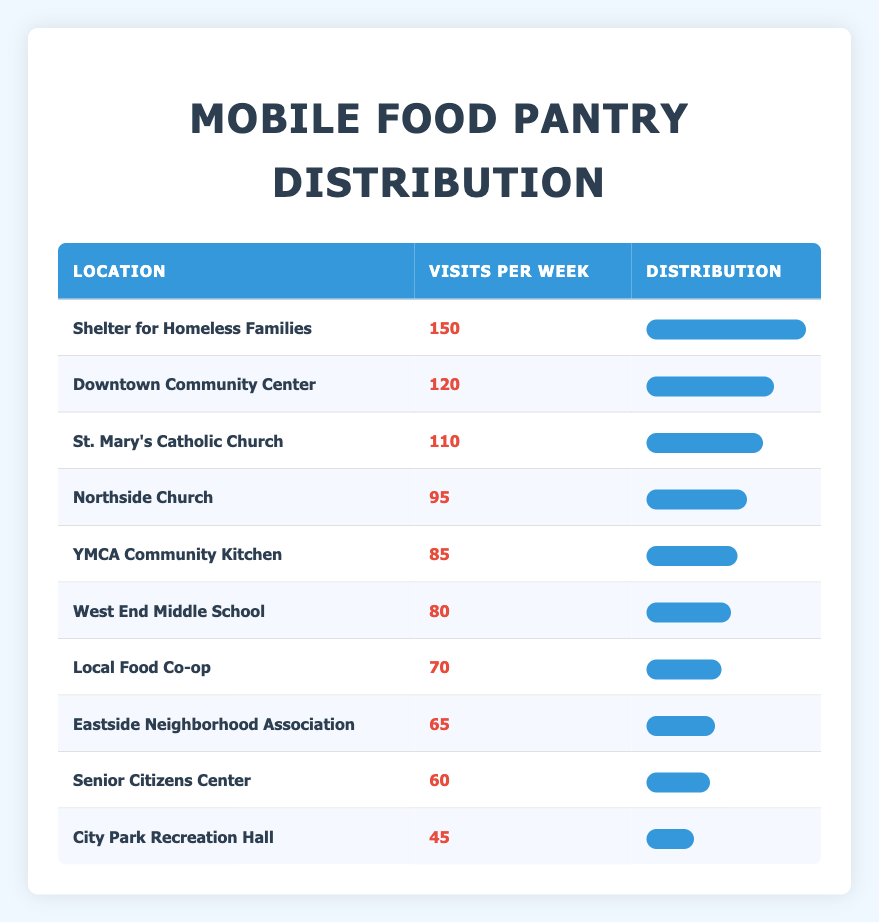What is the highest number of visits per week recorded? The highest number of visits per week is found in the row for "Shelter for Homeless Families," which shows 150 visits.
Answer: 150 Which location has the lowest number of visits per week? According to the table, "City Park Recreation Hall" has the lowest visits per week at 45.
Answer: 45 What is the average number of visits per week across all locations? To calculate the average, sum up all the visits per week: 150 + 120 + 110 + 95 + 85 + 80 + 70 + 65 + 60 + 45 = 1,010. Then, divide by the number of locations, which is 10: 1,010 / 10 = 101.
Answer: 101 Is it true that more than 100 visits per week occurred at four different locations? By checking the table, we see that the locations with more than 100 visits are "Shelter for Homeless Families," "Downtown Community Center," and "St. Mary's Catholic Church," totaling three locations. Therefore, the statement is false.
Answer: No What is the difference in visits between the location with the most visits and the location with the least visits? The most visits are 150 (Shelter for Homeless Families) and the least are 45 (City Park Recreation Hall). The difference is 150 - 45 = 105.
Answer: 105 How many locations have between 60 and 90 visits per week? The table shows locations with visits between 60 and 90: "Eastside Neighborhood Association" (65), "Local Food Co-op" (70), "YMCA Community Kitchen" (85), and "West End Middle School" (80). This totals four locations.
Answer: 4 If you combine the visits from "Downtown Community Center," "Northside Church," and "YMCA Community Kitchen," what is the total? The total is calculated by adding the visits from these three locations: 120 (Downtown Community Center) + 95 (Northside Church) + 85 (YMCA Community Kitchen) = 300.
Answer: 300 Which location has more visits: "St. Mary's Catholic Church" or "YMCA Community Kitchen"? Comparing the two, "St. Mary's Catholic Church" has 110 visits, while "YMCA Community Kitchen" has 85 visits. Since 110 is greater than 85, "St. Mary's Catholic Church" has more visits.
Answer: St. Mary's Catholic Church 